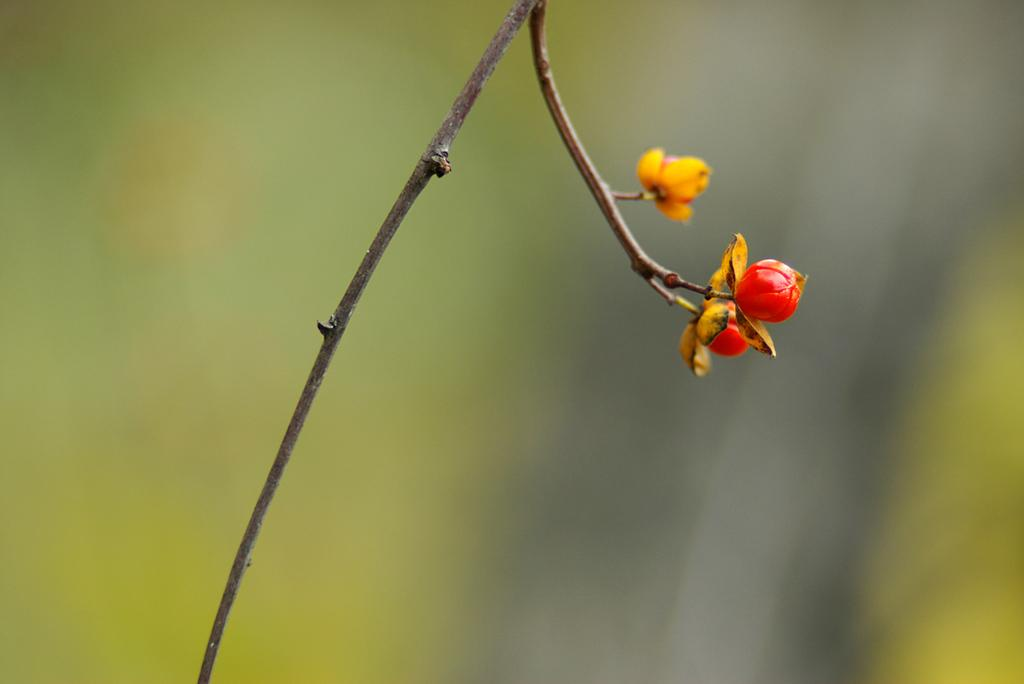What is the main subject of the image? The main subject of the image is a flower bud. Can you describe the background of the image? The background of the image is blurred. What language is the flower bud speaking in the image? There is no indication that the flower bud is speaking in any language, as it is a non-living object. 